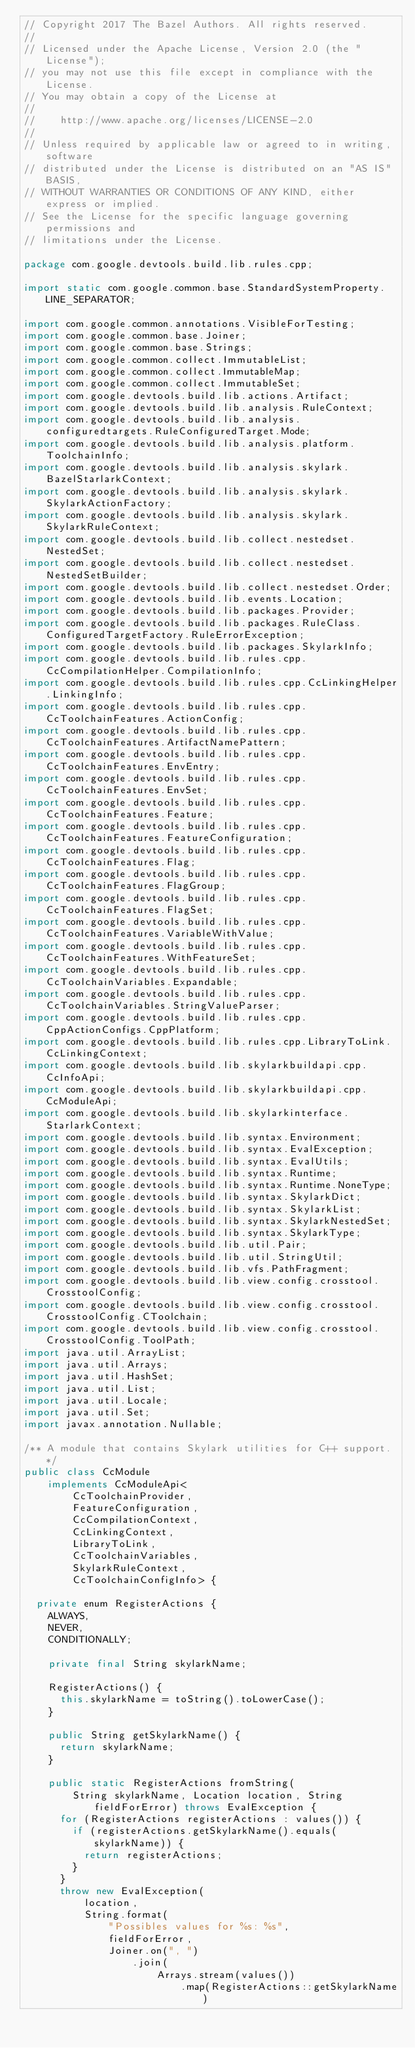<code> <loc_0><loc_0><loc_500><loc_500><_Java_>// Copyright 2017 The Bazel Authors. All rights reserved.
//
// Licensed under the Apache License, Version 2.0 (the "License");
// you may not use this file except in compliance with the License.
// You may obtain a copy of the License at
//
//    http://www.apache.org/licenses/LICENSE-2.0
//
// Unless required by applicable law or agreed to in writing, software
// distributed under the License is distributed on an "AS IS" BASIS,
// WITHOUT WARRANTIES OR CONDITIONS OF ANY KIND, either express or implied.
// See the License for the specific language governing permissions and
// limitations under the License.

package com.google.devtools.build.lib.rules.cpp;

import static com.google.common.base.StandardSystemProperty.LINE_SEPARATOR;

import com.google.common.annotations.VisibleForTesting;
import com.google.common.base.Joiner;
import com.google.common.base.Strings;
import com.google.common.collect.ImmutableList;
import com.google.common.collect.ImmutableMap;
import com.google.common.collect.ImmutableSet;
import com.google.devtools.build.lib.actions.Artifact;
import com.google.devtools.build.lib.analysis.RuleContext;
import com.google.devtools.build.lib.analysis.configuredtargets.RuleConfiguredTarget.Mode;
import com.google.devtools.build.lib.analysis.platform.ToolchainInfo;
import com.google.devtools.build.lib.analysis.skylark.BazelStarlarkContext;
import com.google.devtools.build.lib.analysis.skylark.SkylarkActionFactory;
import com.google.devtools.build.lib.analysis.skylark.SkylarkRuleContext;
import com.google.devtools.build.lib.collect.nestedset.NestedSet;
import com.google.devtools.build.lib.collect.nestedset.NestedSetBuilder;
import com.google.devtools.build.lib.collect.nestedset.Order;
import com.google.devtools.build.lib.events.Location;
import com.google.devtools.build.lib.packages.Provider;
import com.google.devtools.build.lib.packages.RuleClass.ConfiguredTargetFactory.RuleErrorException;
import com.google.devtools.build.lib.packages.SkylarkInfo;
import com.google.devtools.build.lib.rules.cpp.CcCompilationHelper.CompilationInfo;
import com.google.devtools.build.lib.rules.cpp.CcLinkingHelper.LinkingInfo;
import com.google.devtools.build.lib.rules.cpp.CcToolchainFeatures.ActionConfig;
import com.google.devtools.build.lib.rules.cpp.CcToolchainFeatures.ArtifactNamePattern;
import com.google.devtools.build.lib.rules.cpp.CcToolchainFeatures.EnvEntry;
import com.google.devtools.build.lib.rules.cpp.CcToolchainFeatures.EnvSet;
import com.google.devtools.build.lib.rules.cpp.CcToolchainFeatures.Feature;
import com.google.devtools.build.lib.rules.cpp.CcToolchainFeatures.FeatureConfiguration;
import com.google.devtools.build.lib.rules.cpp.CcToolchainFeatures.Flag;
import com.google.devtools.build.lib.rules.cpp.CcToolchainFeatures.FlagGroup;
import com.google.devtools.build.lib.rules.cpp.CcToolchainFeatures.FlagSet;
import com.google.devtools.build.lib.rules.cpp.CcToolchainFeatures.VariableWithValue;
import com.google.devtools.build.lib.rules.cpp.CcToolchainFeatures.WithFeatureSet;
import com.google.devtools.build.lib.rules.cpp.CcToolchainVariables.Expandable;
import com.google.devtools.build.lib.rules.cpp.CcToolchainVariables.StringValueParser;
import com.google.devtools.build.lib.rules.cpp.CppActionConfigs.CppPlatform;
import com.google.devtools.build.lib.rules.cpp.LibraryToLink.CcLinkingContext;
import com.google.devtools.build.lib.skylarkbuildapi.cpp.CcInfoApi;
import com.google.devtools.build.lib.skylarkbuildapi.cpp.CcModuleApi;
import com.google.devtools.build.lib.skylarkinterface.StarlarkContext;
import com.google.devtools.build.lib.syntax.Environment;
import com.google.devtools.build.lib.syntax.EvalException;
import com.google.devtools.build.lib.syntax.EvalUtils;
import com.google.devtools.build.lib.syntax.Runtime;
import com.google.devtools.build.lib.syntax.Runtime.NoneType;
import com.google.devtools.build.lib.syntax.SkylarkDict;
import com.google.devtools.build.lib.syntax.SkylarkList;
import com.google.devtools.build.lib.syntax.SkylarkNestedSet;
import com.google.devtools.build.lib.syntax.SkylarkType;
import com.google.devtools.build.lib.util.Pair;
import com.google.devtools.build.lib.util.StringUtil;
import com.google.devtools.build.lib.vfs.PathFragment;
import com.google.devtools.build.lib.view.config.crosstool.CrosstoolConfig;
import com.google.devtools.build.lib.view.config.crosstool.CrosstoolConfig.CToolchain;
import com.google.devtools.build.lib.view.config.crosstool.CrosstoolConfig.ToolPath;
import java.util.ArrayList;
import java.util.Arrays;
import java.util.HashSet;
import java.util.List;
import java.util.Locale;
import java.util.Set;
import javax.annotation.Nullable;

/** A module that contains Skylark utilities for C++ support. */
public class CcModule
    implements CcModuleApi<
        CcToolchainProvider,
        FeatureConfiguration,
        CcCompilationContext,
        CcLinkingContext,
        LibraryToLink,
        CcToolchainVariables,
        SkylarkRuleContext,
        CcToolchainConfigInfo> {

  private enum RegisterActions {
    ALWAYS,
    NEVER,
    CONDITIONALLY;

    private final String skylarkName;

    RegisterActions() {
      this.skylarkName = toString().toLowerCase();
    }

    public String getSkylarkName() {
      return skylarkName;
    }

    public static RegisterActions fromString(
        String skylarkName, Location location, String fieldForError) throws EvalException {
      for (RegisterActions registerActions : values()) {
        if (registerActions.getSkylarkName().equals(skylarkName)) {
          return registerActions;
        }
      }
      throw new EvalException(
          location,
          String.format(
              "Possibles values for %s: %s",
              fieldForError,
              Joiner.on(", ")
                  .join(
                      Arrays.stream(values())
                          .map(RegisterActions::getSkylarkName)</code> 